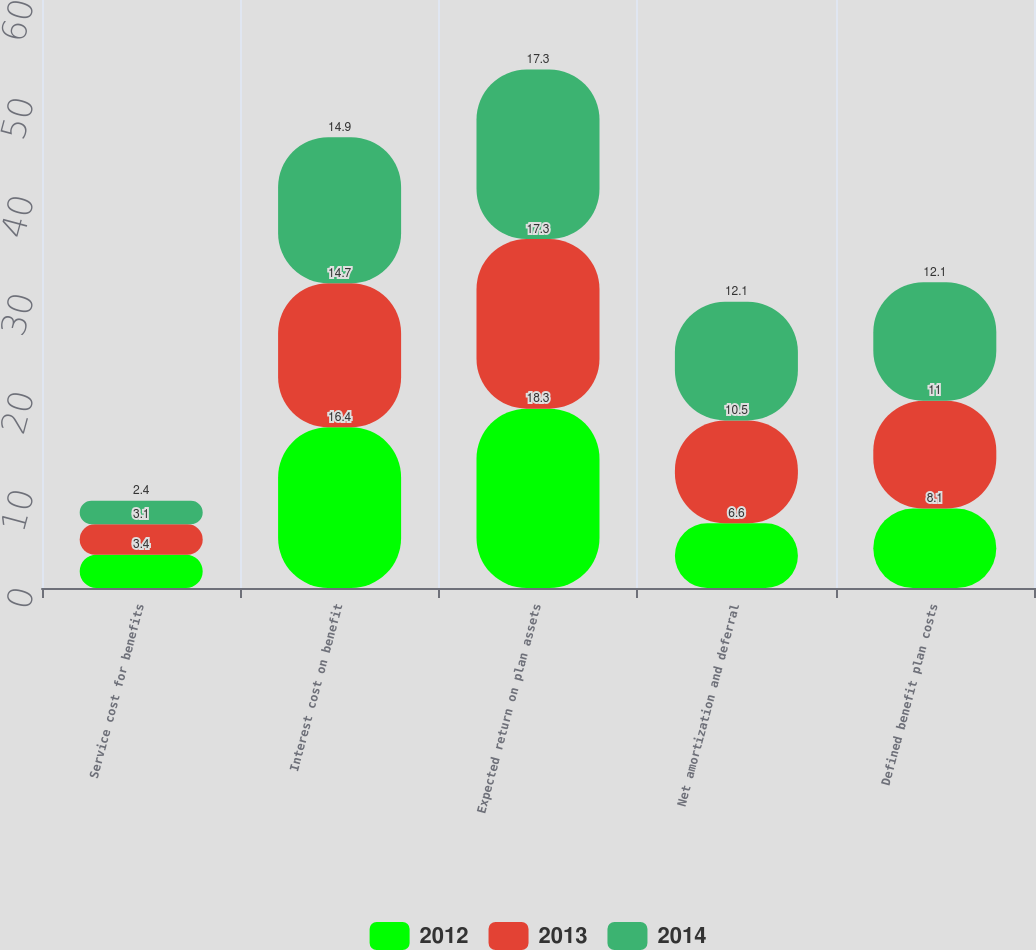Convert chart. <chart><loc_0><loc_0><loc_500><loc_500><stacked_bar_chart><ecel><fcel>Service cost for benefits<fcel>Interest cost on benefit<fcel>Expected return on plan assets<fcel>Net amortization and deferral<fcel>Defined benefit plan costs<nl><fcel>2012<fcel>3.4<fcel>16.4<fcel>18.3<fcel>6.6<fcel>8.1<nl><fcel>2013<fcel>3.1<fcel>14.7<fcel>17.3<fcel>10.5<fcel>11<nl><fcel>2014<fcel>2.4<fcel>14.9<fcel>17.3<fcel>12.1<fcel>12.1<nl></chart> 